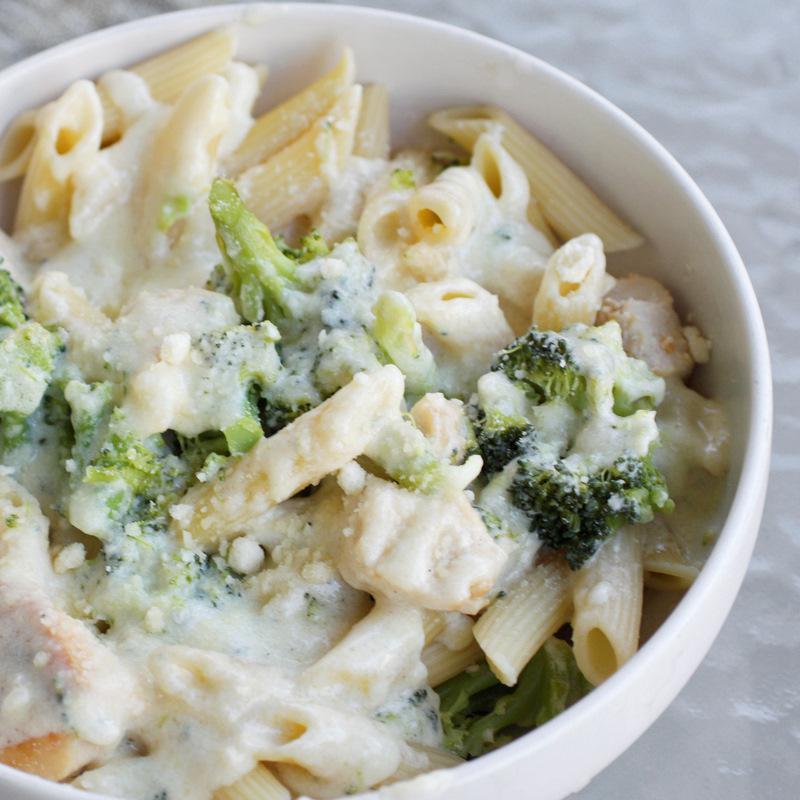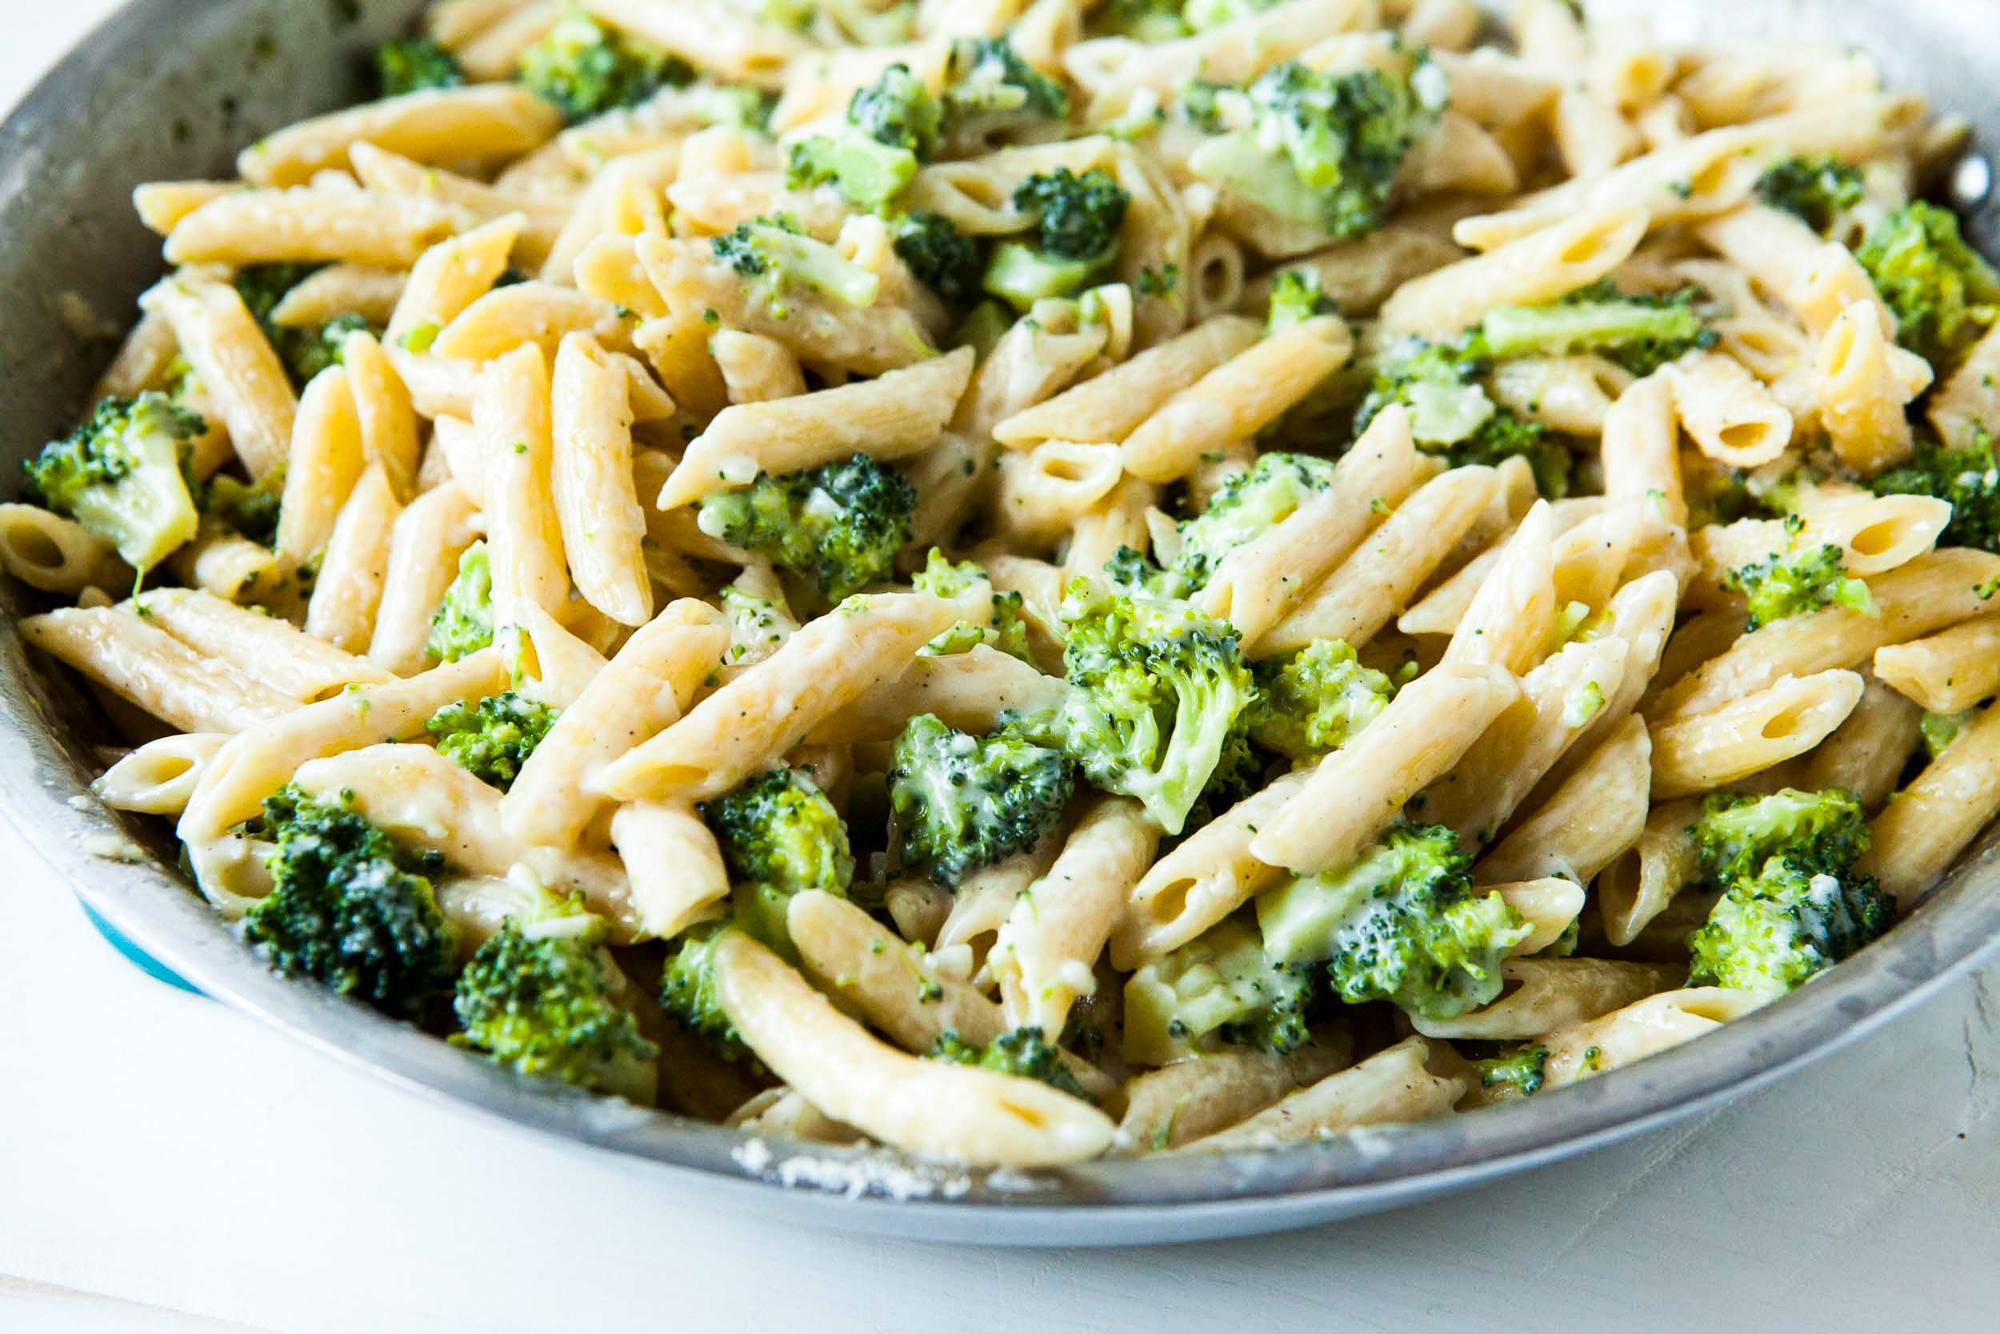The first image is the image on the left, the second image is the image on the right. Assess this claim about the two images: "One image shows a pasta dish served in a mahogany colored bowl.". Correct or not? Answer yes or no. No. 